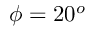<formula> <loc_0><loc_0><loc_500><loc_500>\phi = 2 0 ^ { o }</formula> 